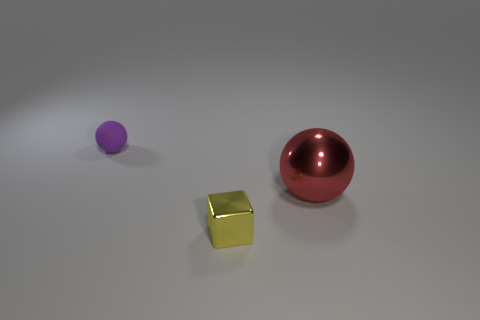What number of metallic things are small yellow cubes or spheres?
Make the answer very short. 2. What is the shape of the big red metallic thing?
Your answer should be compact. Sphere. How many tiny cubes have the same material as the small purple ball?
Provide a succinct answer. 0. The tiny cube that is the same material as the big thing is what color?
Ensure brevity in your answer.  Yellow. Does the ball that is in front of the purple matte sphere have the same size as the tiny shiny block?
Give a very brief answer. No. The small rubber thing that is the same shape as the large object is what color?
Ensure brevity in your answer.  Purple. The small object that is behind the ball in front of the ball left of the yellow shiny cube is what shape?
Make the answer very short. Sphere. Does the small yellow object have the same shape as the red object?
Ensure brevity in your answer.  No. There is a small thing in front of the object on the left side of the shiny block; what shape is it?
Provide a succinct answer. Cube. Is there a large shiny ball?
Provide a succinct answer. Yes. 